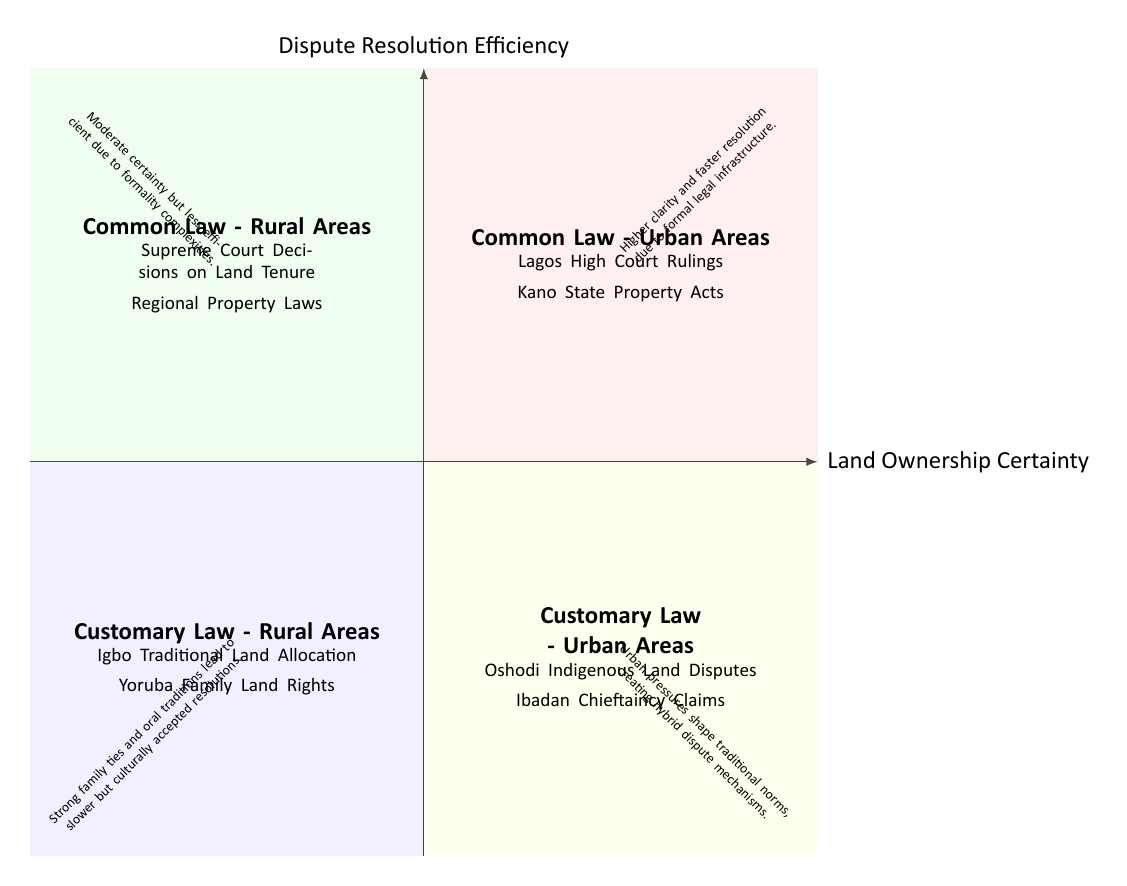What is the label of the top right quadrant? The top right quadrant is labeled "Common Law - Urban Areas."
Answer: Common Law - Urban Areas What examples are listed in the bottom left quadrant? The bottom left quadrant includes "Igbo Traditional Land Allocation" and "Yoruba Family Land Rights."
Answer: Igbo Traditional Land Allocation, Yoruba Family Land Rights Which quadrant describes dispute resolution efficiency as being higher? The top right quadrant describes higher efficiency, stating, "Higher clarity and faster resolution due to formal legal infrastructure."
Answer: Top right quadrant What is the efficiency description for the bottom right quadrant? The bottom right quadrant notes that "Urban pressures shape traditional norms, creating hybrid dispute mechanisms."
Answer: Urban pressures shape traditional norms, creating hybrid dispute mechanisms How does the dispute resolution efficiency compare between "Common Law - Rural Areas" and "Customary Law - Rural Areas"? "Common Law - Rural Areas" has a moderate certainty but is less efficient, while "Customary Law - Rural Areas" leads to slower resolutions but culturally accepted ones, indicating that customary law might take longer.
Answer: Customary Law - Rural Areas is slower What are the examples provided for "Common Law - Rural Areas"? The examples provided include "Supreme Court Decisions on Land Tenure" and "Regional Property Laws."
Answer: Supreme Court Decisions on Land Tenure, Regional Property Laws Which quadrant indicates slower resolutions? The bottom left quadrant indicates slower resolutions, stating "Strong family ties and oral traditions lead to slower but culturally accepted resolutions."
Answer: Bottom left quadrant How many quadrants are shown in the diagram? There are four quadrants shown in the diagram, each representing different legal outcomes.
Answer: Four quadrants What are the characteristics of dispute resolution efficiency in "Common Law - Urban Areas"? In "Common Law - Urban Areas," it is characterized by higher clarity and faster resolution due to formal legal infrastructure.
Answer: Higher clarity and faster resolution 